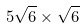<formula> <loc_0><loc_0><loc_500><loc_500>5 \sqrt { 6 } \times \sqrt { 6 }</formula> 